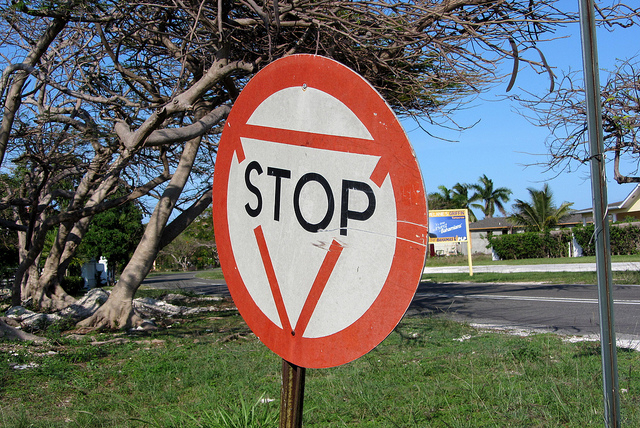Please transcribe the text in this image. STOP 